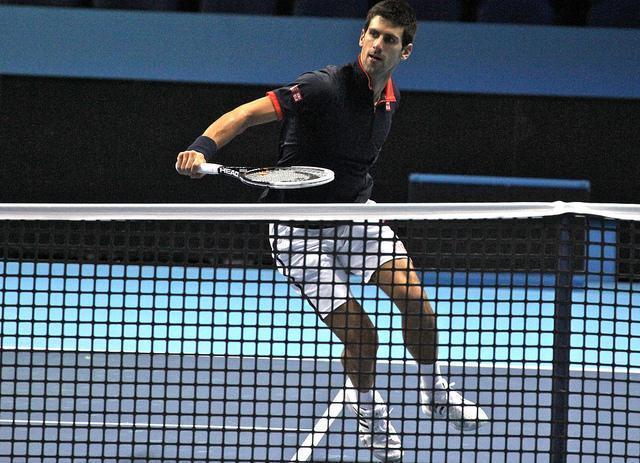How many tennis rackets are there?
Give a very brief answer. 1. 